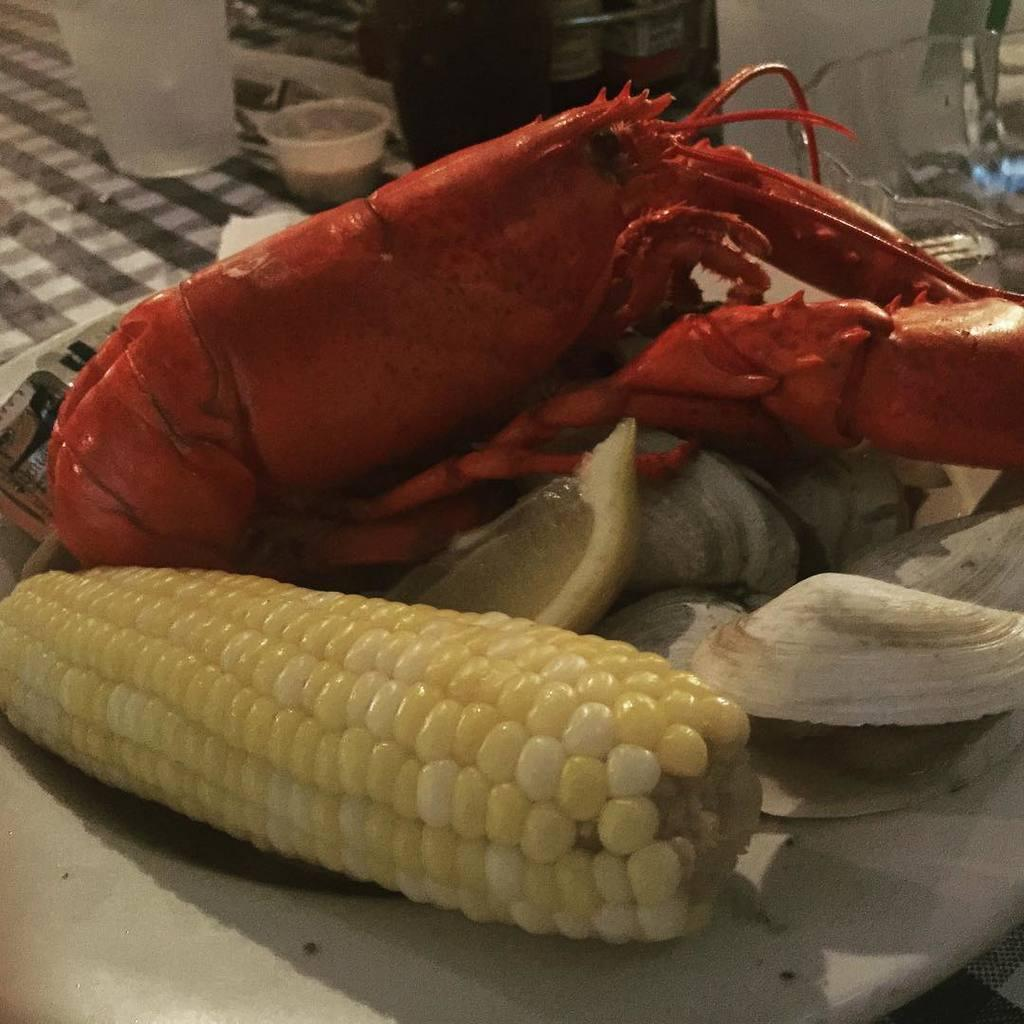What type of food item is present in the image? There is a food item in the image, which is corn. How is the corn presented in the image? The corn is in a glass bowl in the image. Can you describe any other objects in the image besides the corn and the bowl? There are some unspecified objects in the image, but their nature is not clear from the provided facts. What type of protest is taking place in the image? There is no protest present in the image; it features corn in a glass bowl and some unspecified objects. What color is the horse in the image? There is no horse present in the image; it features corn in a glass bowl and some unspecified objects. 